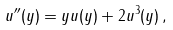Convert formula to latex. <formula><loc_0><loc_0><loc_500><loc_500>u ^ { \prime \prime } ( y ) = y u ( y ) + 2 u ^ { 3 } ( y ) \, ,</formula> 